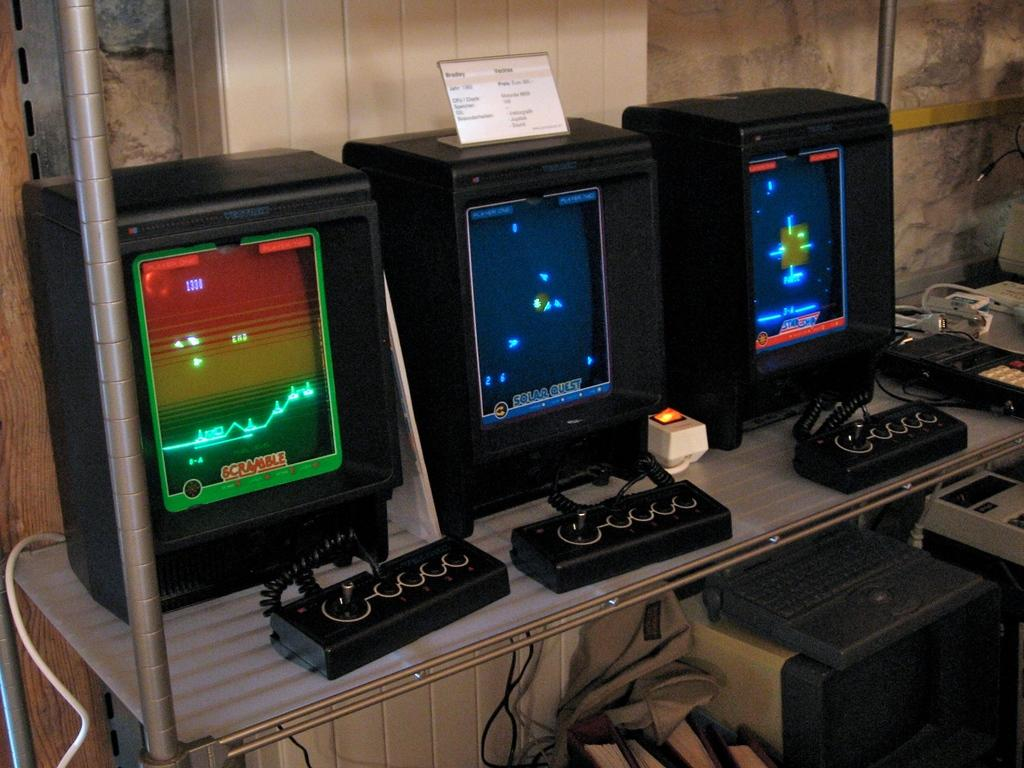<image>
Summarize the visual content of the image. An old video game called Scramble is open on a monitor. 